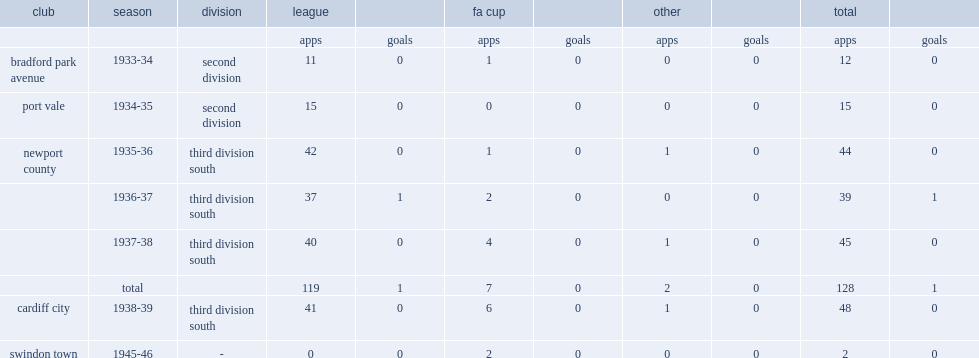Which club did jim kelso play for in 1935-36? Newport county. 